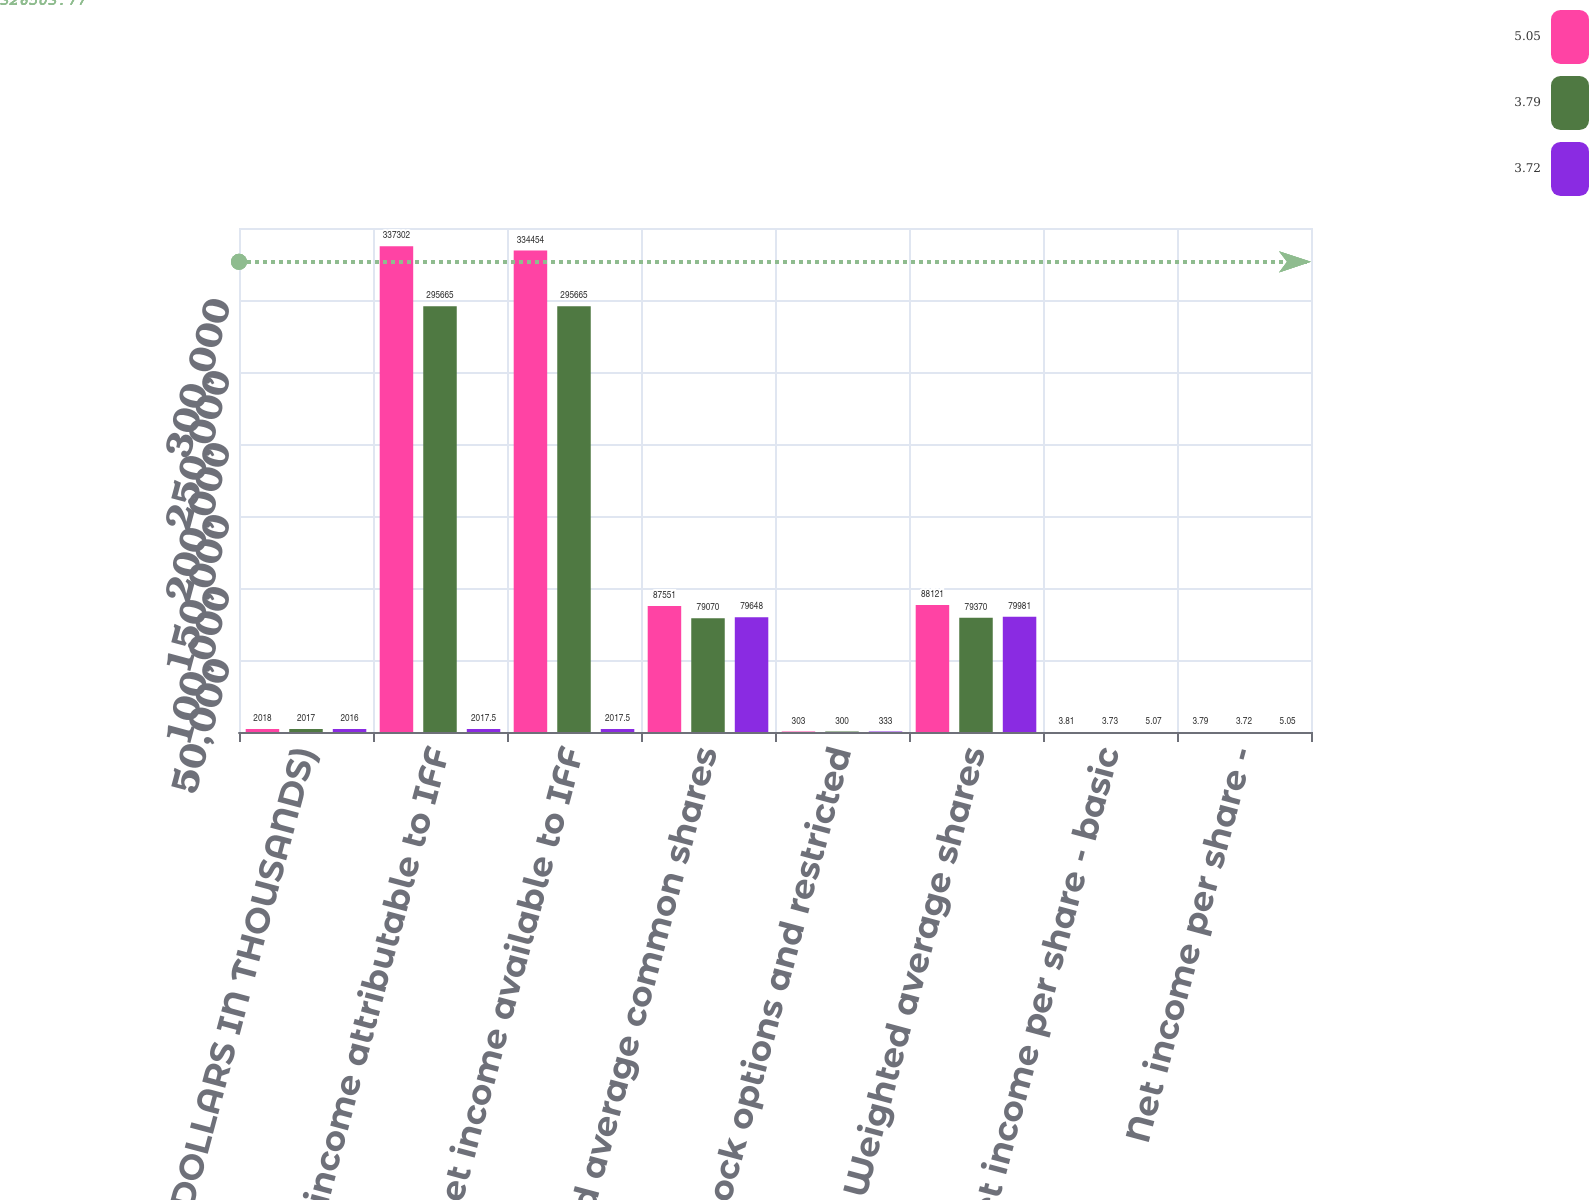Convert chart. <chart><loc_0><loc_0><loc_500><loc_500><stacked_bar_chart><ecel><fcel>(DOLLARS IN THOUSANDS)<fcel>Net income attributable to IFF<fcel>Net income available to IFF<fcel>Weighted average common shares<fcel>Stock options and restricted<fcel>Weighted average shares<fcel>Net income per share - basic<fcel>Net income per share -<nl><fcel>5.05<fcel>2018<fcel>337302<fcel>334454<fcel>87551<fcel>303<fcel>88121<fcel>3.81<fcel>3.79<nl><fcel>3.79<fcel>2017<fcel>295665<fcel>295665<fcel>79070<fcel>300<fcel>79370<fcel>3.73<fcel>3.72<nl><fcel>3.72<fcel>2016<fcel>2017.5<fcel>2017.5<fcel>79648<fcel>333<fcel>79981<fcel>5.07<fcel>5.05<nl></chart> 